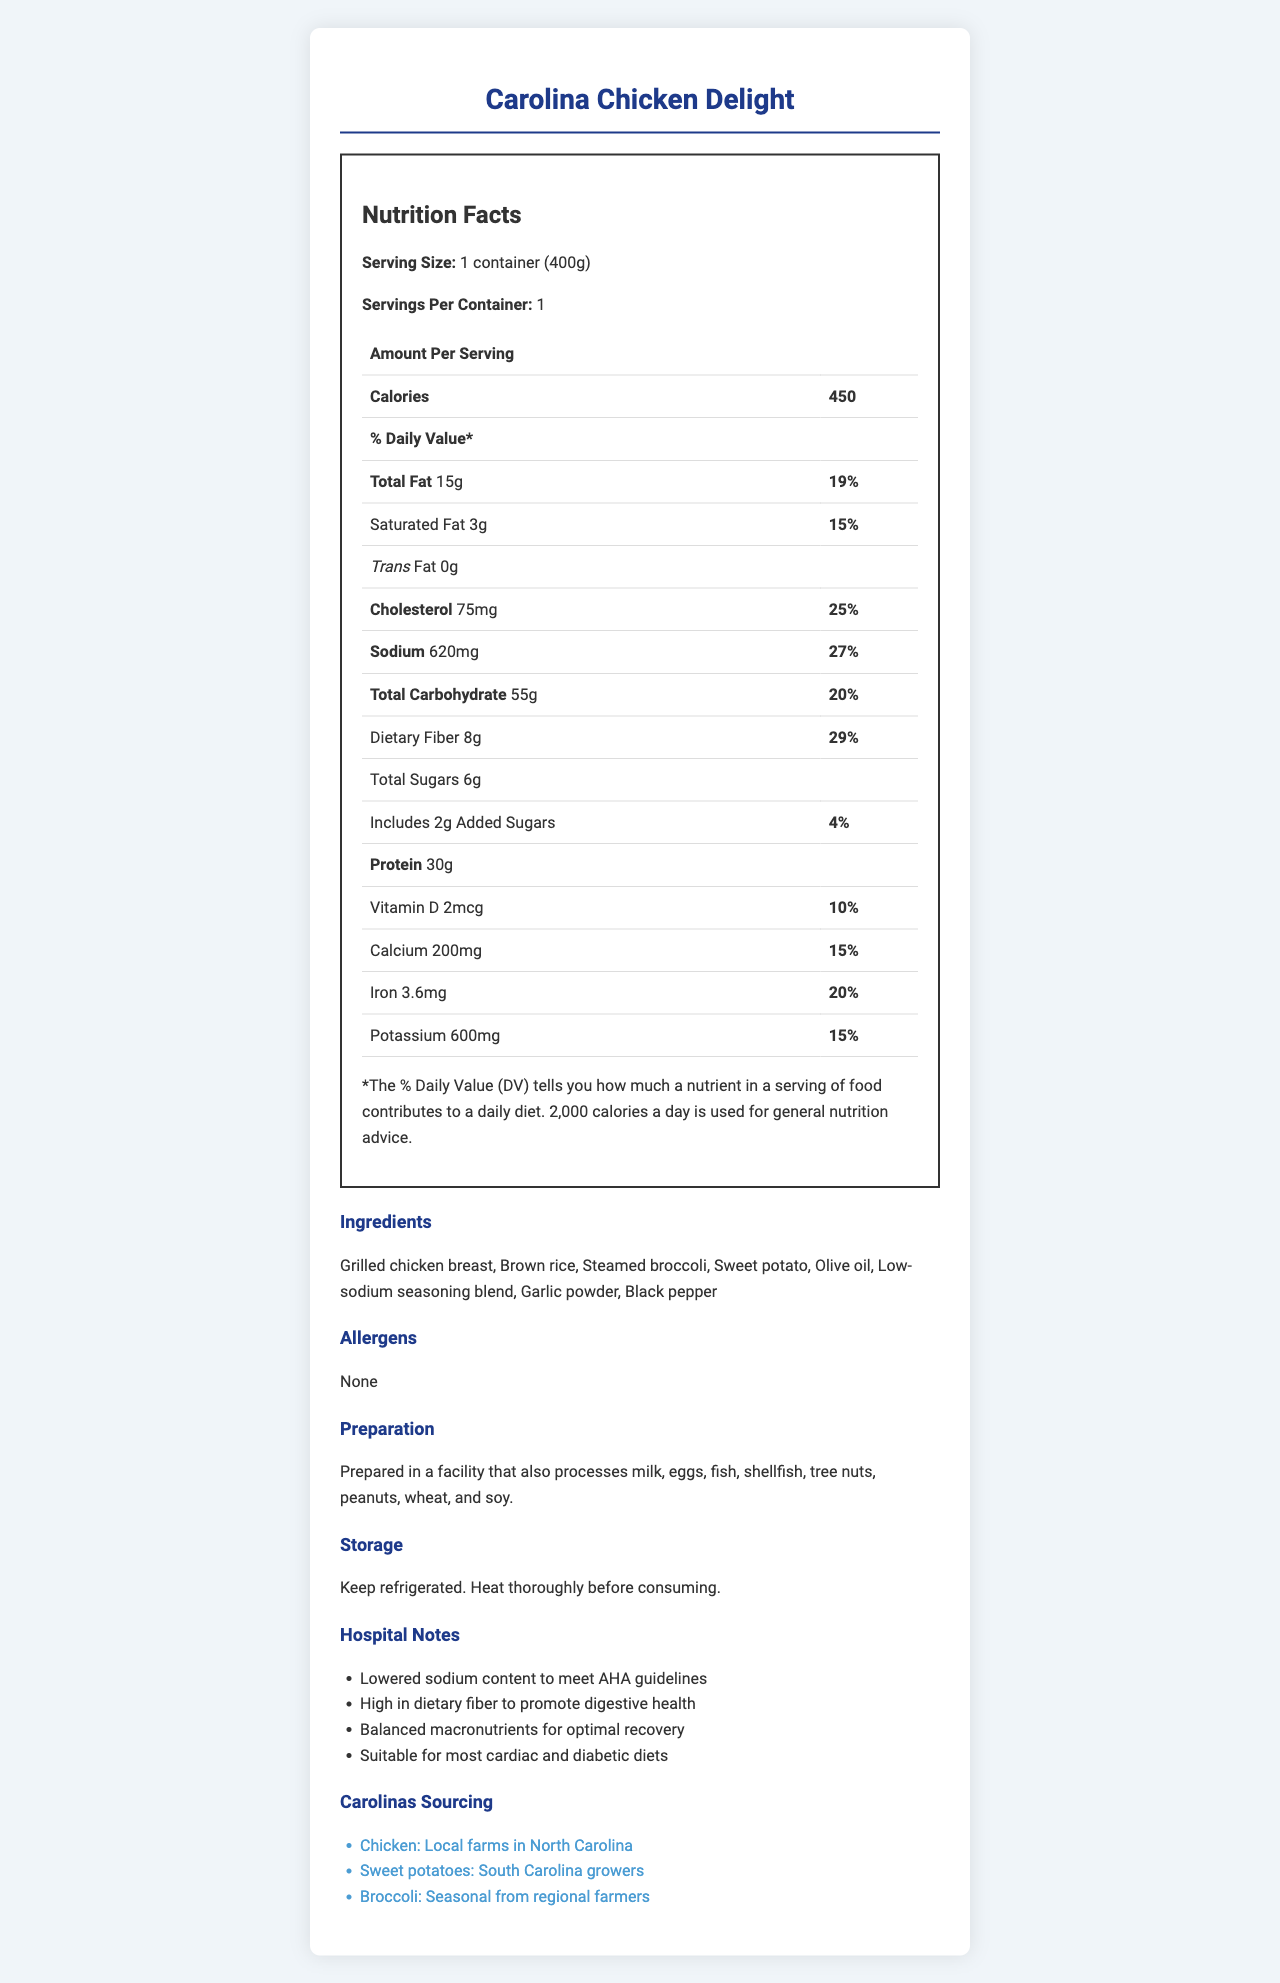what is the serving size of the Carolina Chicken Delight meal? The serving size is mentioned as "1 container (400g)" in the Nutrition Facts Label.
Answer: 1 container (400g) how much sodium is in a serving of Carolina Chicken Delight? The sodium content per serving is listed as 620mg in the Nutrition Facts Label.
Answer: 620mg what percentage of the daily value does the dietary fiber content of Carolina Chicken Delight represent? The dietary fiber content has a daily value percentage of 29% as per the Nutrition Facts Label.
Answer: 29% what ingredients are used in the Carolina Chicken Delight meal? The ingredients section lists all the ingredients used in the meal.
Answer: Grilled chicken breast, Brown rice, Steamed broccoli, Sweet potato, Olive oil, Low-sodium seasoning blend, Garlic powder, Black pepper what are the preparation instructions for the Carolina Chicken Delight meal? The preparation section mentions "Prepared in a facility that also processes milk, eggs, fish, shellfish, tree nuts, peanuts, wheat, and soy."
Answer: Prepared in a facility that also processes milk, eggs, fish, shellfish, tree nuts, peanuts, wheat, and soy. how many grams of total fat does a serving of this meal contain? The total fat content is given as 15g in the Nutrition Facts Label.
Answer: 15g is the Carolina Chicken Delight meal suitable for most cardiac and diabetic diets? One of the hospital notes states that the meal is "Suitable for most cardiac and diabetic diets."
Answer: Yes what is the carbohydrate content of the Carolina Chicken Delight meal? A. 30g B. 55g C. 75g The total carbohydrate content per serving is listed as 55g.
Answer: B how much protein does the Carolina Chicken Delight meal contain per serving? A. 10g B. 20g C. 30g The protein content per serving is 30g as shown in the Nutrition Facts Label.
Answer: C does the meal contain any trans fat? The Nutrition Facts Label lists the trans fat content as 0g.
Answer: No write a summary of the document focusing on the nutritional and ingredient aspects of the Carolina Chicken Delight meal. The summary provides a detailed overview of the nutritional content and ingredients of the Carolina Chicken Delight meal, along with additional contextual information mentioned in the document.
Answer: The Carolina Chicken Delight meal is a pre-packaged hospital meal with a serving size of 1 container (400g) and contains 450 calories. It provides 15g of total fat, 3g of saturated fat, 0g of trans fat, 75mg of cholesterol, and 620mg of sodium. The meal is high in dietary fiber with 8g, representing 29% of the daily value. Additionally, it contains 6g of total sugars, including 2g of added sugars, and 30g of protein. The meal includes ingredients like grilled chicken breast, brown rice, and steamed broccoli. It is prepared in a facility that processes various allergens, though none are directly present in this meal. The meal is tailored to meet lower sodium guidelines and is described as suitable for most cardiac and diabetic diets, with sourcing from local Carolinas farmers. can you identify where the chicken in the meal is sourced from? The Carolinas sourcing section indicates that the chicken is sourced from local farms in North Carolina.
Answer: Local farms in North Carolina what is the daily value percentage of sodium in the Carolina Chicken Delight meal? The daily value percentage for sodium is 27% as stated in the Nutrition Facts Label.
Answer: 27% can this meal contain peanuts? The document states that it is prepared in a facility that processes peanuts, but it does not clearly indicate whether peanuts are used directly in this meal.
Answer: Cannot be determined 